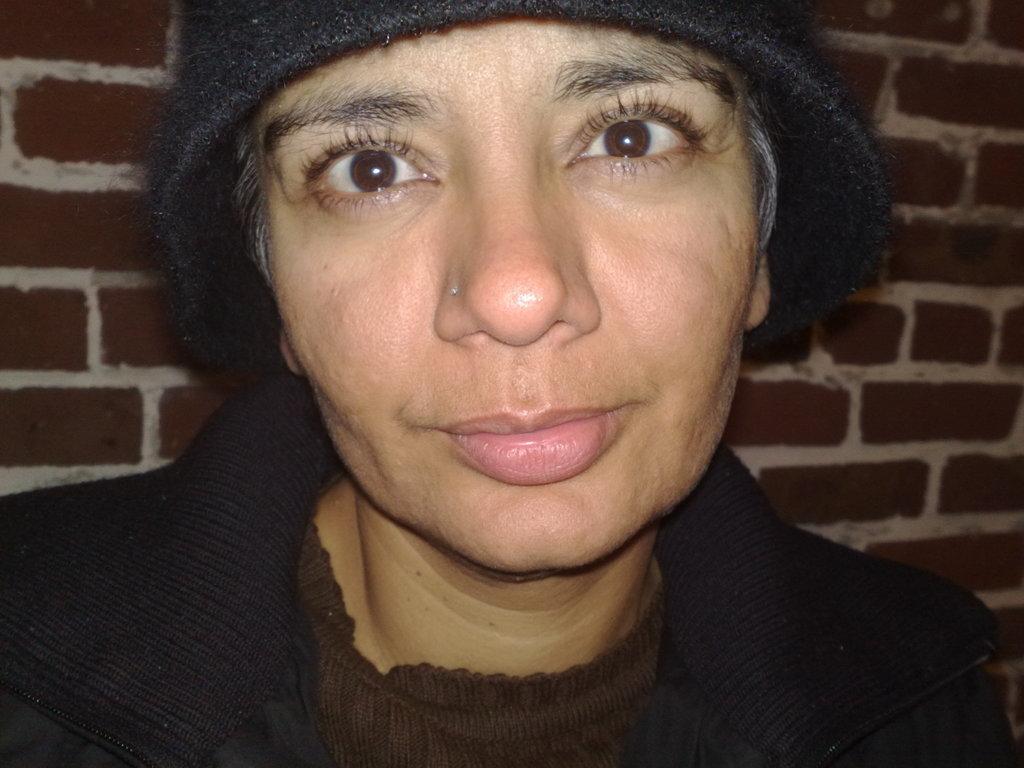Please provide a concise description of this image. In this picture we can see a woman wore a cap, smiling and in the background we can see the wall. 